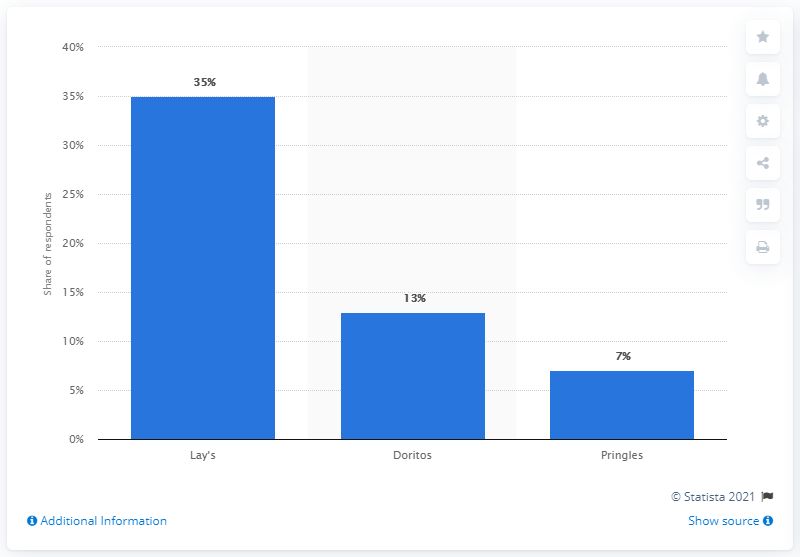Outline some significant characteristics in this image. In the past, the preferred potato chip brand for road trips was Doritos. 